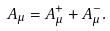<formula> <loc_0><loc_0><loc_500><loc_500>A _ { \mu } = A _ { \mu } ^ { + } + A _ { \mu } ^ { - } .</formula> 